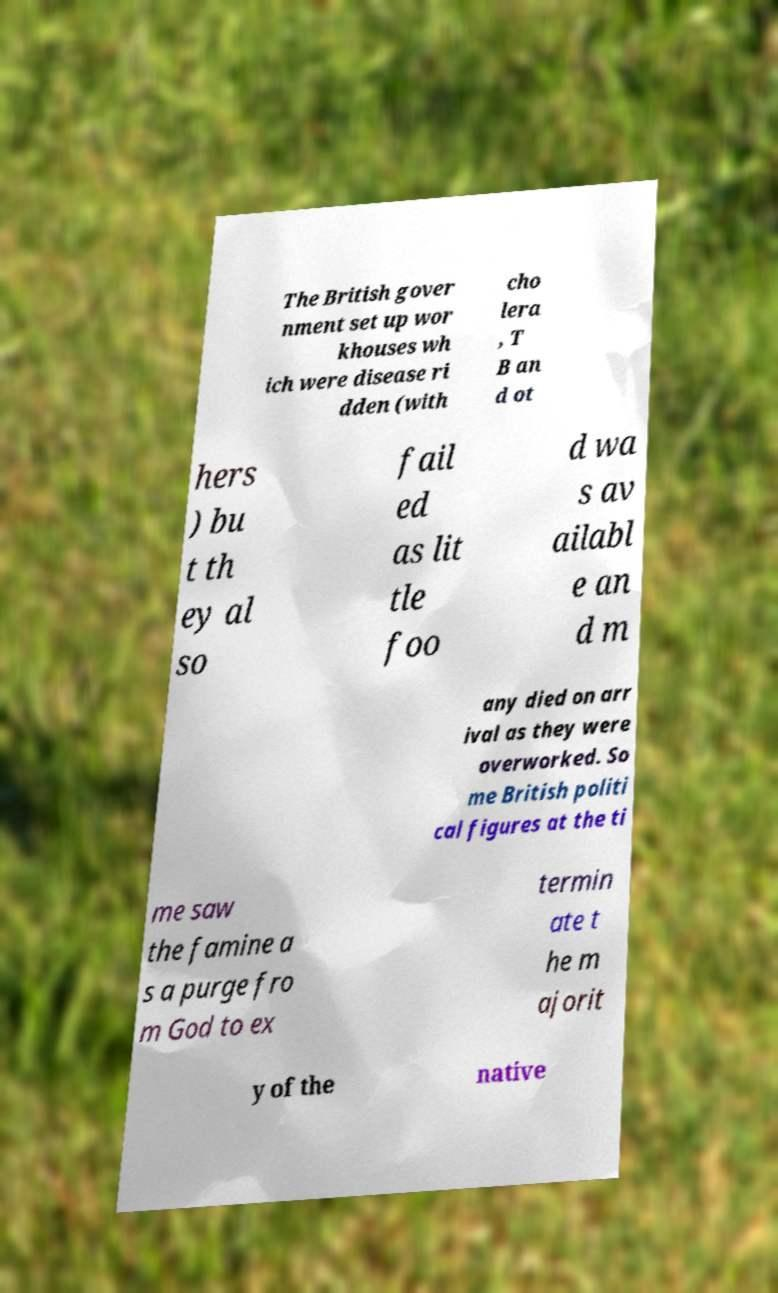I need the written content from this picture converted into text. Can you do that? The British gover nment set up wor khouses wh ich were disease ri dden (with cho lera , T B an d ot hers ) bu t th ey al so fail ed as lit tle foo d wa s av ailabl e an d m any died on arr ival as they were overworked. So me British politi cal figures at the ti me saw the famine a s a purge fro m God to ex termin ate t he m ajorit y of the native 